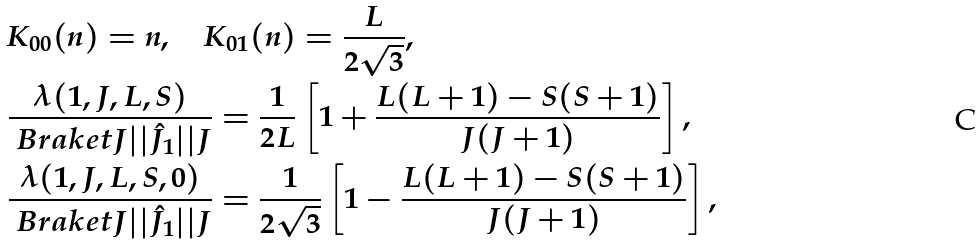<formula> <loc_0><loc_0><loc_500><loc_500>& K _ { 0 0 } ( n ) = n , \quad K _ { 0 1 } ( n ) = \frac { L } { 2 \sqrt { 3 } } , \\ & \frac { \lambda ( 1 , J , L , S ) } { \ B r a k e t { J | | \hat { J } _ { 1 } | | J } } = \frac { 1 } { 2 L } \left [ 1 + \frac { L ( L + 1 ) - S ( S + 1 ) } { J ( J + 1 ) } \right ] , \\ & \frac { \lambda ( 1 , J , L , S , 0 ) } { \ B r a k e t { J | | \hat { J } _ { 1 } | | J } } = \frac { 1 } { 2 \sqrt { 3 } } \left [ 1 - \frac { L ( L + 1 ) - S ( S + 1 ) } { J ( J + 1 ) } \right ] ,</formula> 